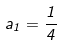Convert formula to latex. <formula><loc_0><loc_0><loc_500><loc_500>a _ { 1 } = { \frac { 1 } { 4 } }</formula> 